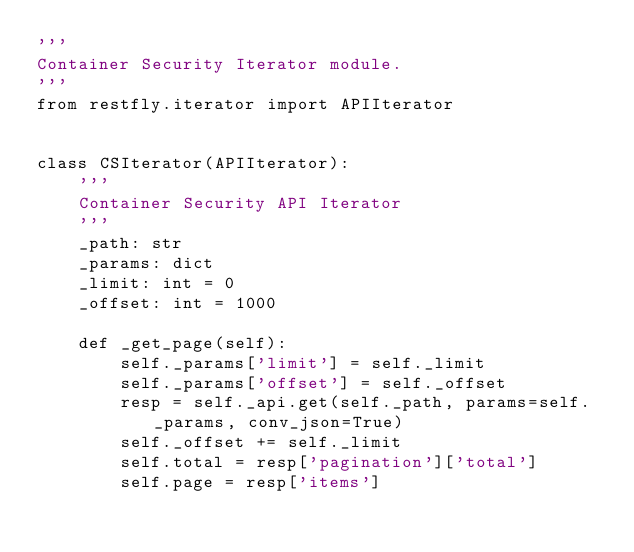<code> <loc_0><loc_0><loc_500><loc_500><_Python_>'''
Container Security Iterator module.
'''
from restfly.iterator import APIIterator


class CSIterator(APIIterator):
    '''
    Container Security API Iterator
    '''
    _path: str
    _params: dict
    _limit: int = 0
    _offset: int = 1000

    def _get_page(self):
        self._params['limit'] = self._limit
        self._params['offset'] = self._offset
        resp = self._api.get(self._path, params=self._params, conv_json=True)
        self._offset += self._limit
        self.total = resp['pagination']['total']
        self.page = resp['items']
</code> 